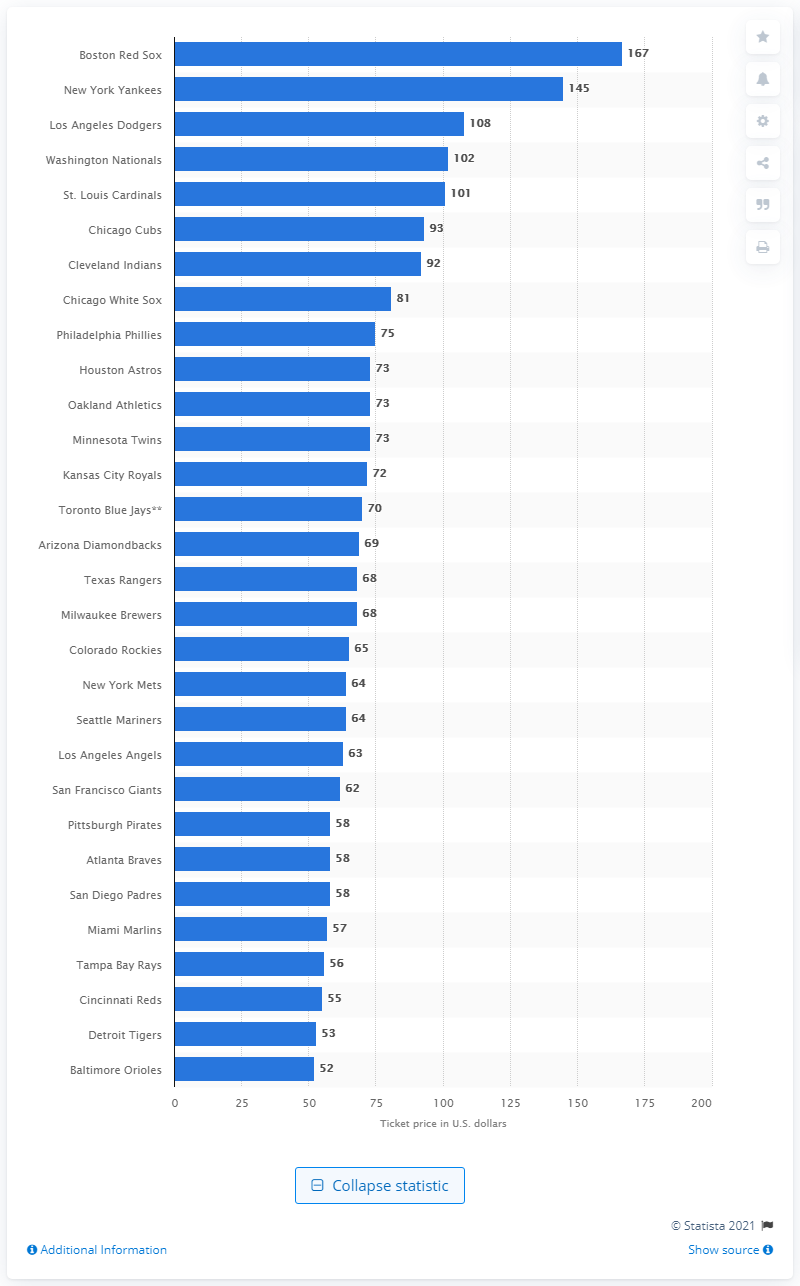Indicate a few pertinent items in this graphic. The ticket price for the Baltimore Orioles is currently $52. The ticket price for the Boston Red Sox is $167. The ticket price for the Baltimore Orioles is 52 dollars. 